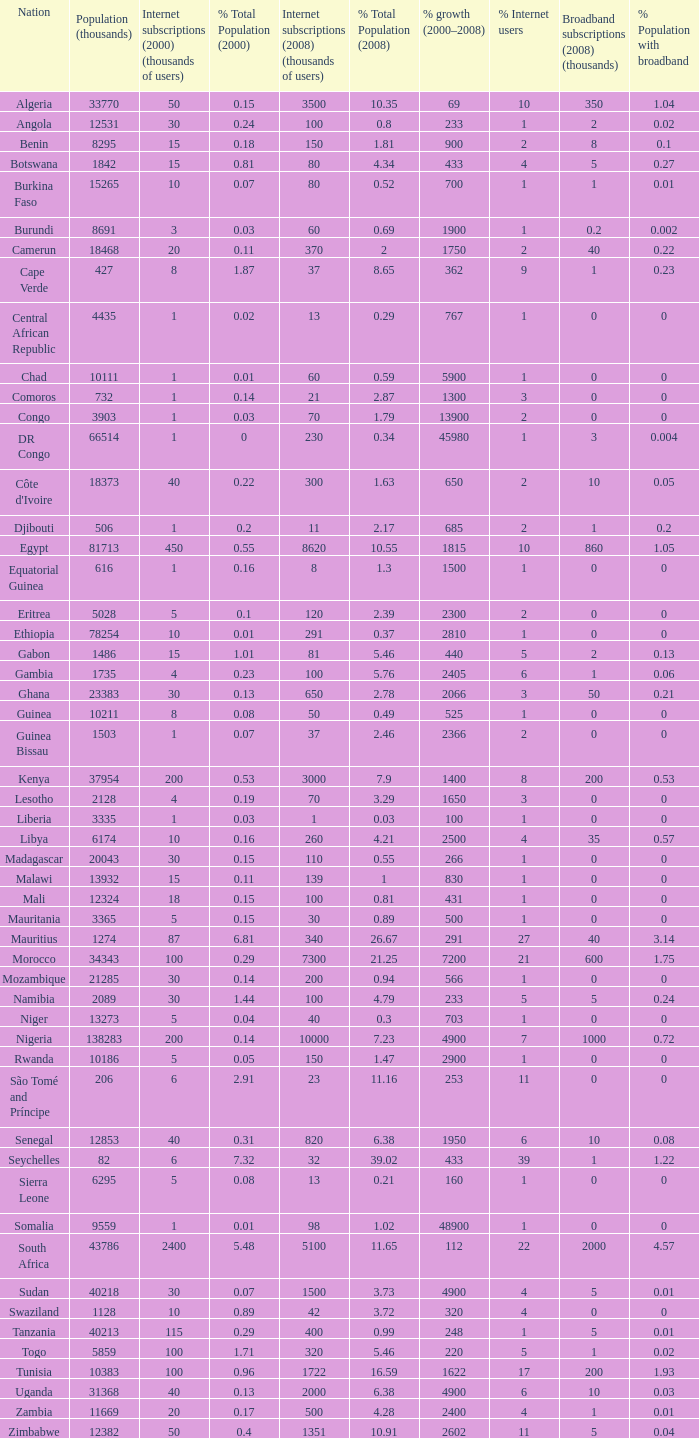What is the percentage of growth in 2000-2008 in ethiopia? 2810.0. 